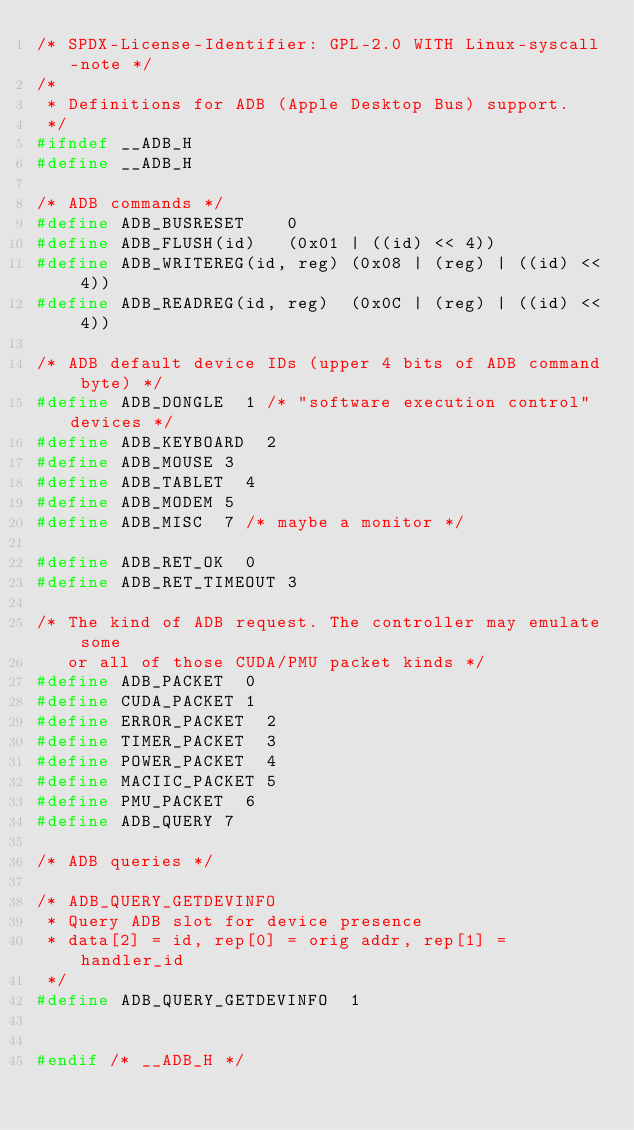<code> <loc_0><loc_0><loc_500><loc_500><_C_>/* SPDX-License-Identifier: GPL-2.0 WITH Linux-syscall-note */
/*
 * Definitions for ADB (Apple Desktop Bus) support.
 */
#ifndef __ADB_H
#define __ADB_H

/* ADB commands */
#define ADB_BUSRESET		0
#define ADB_FLUSH(id)		(0x01 | ((id) << 4))
#define ADB_WRITEREG(id, reg)	(0x08 | (reg) | ((id) << 4))
#define ADB_READREG(id, reg)	(0x0C | (reg) | ((id) << 4))

/* ADB default device IDs (upper 4 bits of ADB command byte) */
#define ADB_DONGLE	1	/* "software execution control" devices */
#define ADB_KEYBOARD	2
#define ADB_MOUSE	3
#define ADB_TABLET	4
#define ADB_MODEM	5
#define ADB_MISC	7	/* maybe a monitor */

#define ADB_RET_OK	0
#define ADB_RET_TIMEOUT	3

/* The kind of ADB request. The controller may emulate some
   or all of those CUDA/PMU packet kinds */
#define ADB_PACKET	0
#define CUDA_PACKET	1
#define ERROR_PACKET	2
#define TIMER_PACKET	3
#define POWER_PACKET	4
#define MACIIC_PACKET	5
#define PMU_PACKET	6
#define ADB_QUERY	7

/* ADB queries */

/* ADB_QUERY_GETDEVINFO
 * Query ADB slot for device presence
 * data[2] = id, rep[0] = orig addr, rep[1] = handler_id
 */
#define ADB_QUERY_GETDEVINFO	1


#endif /* __ADB_H */</code> 